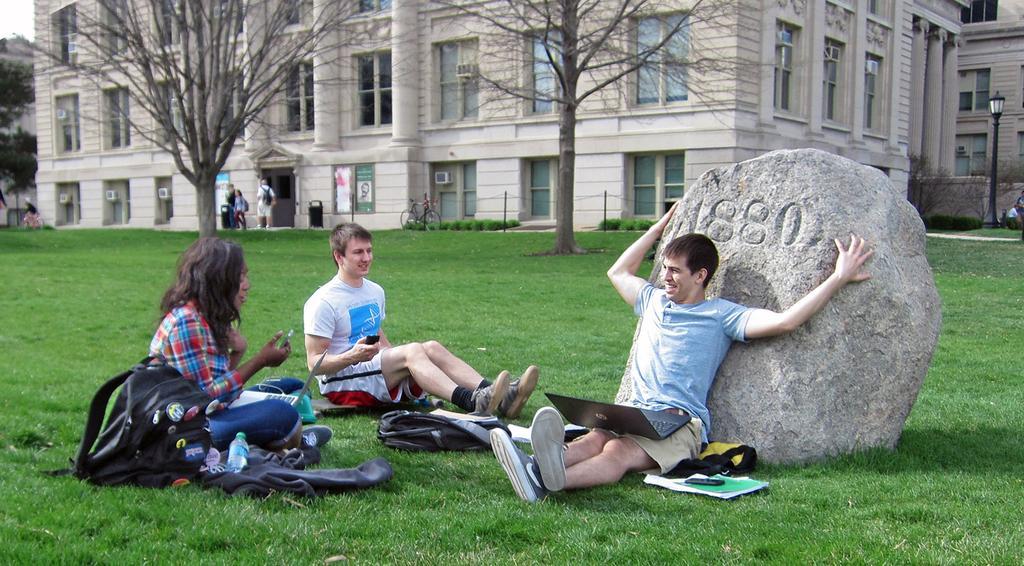Please provide a concise description of this image. In this image there are three people sitting on the grass and on the grass there are stones, books, mobile phone, water bottle and bags. In the background there are trees and also buildings and also few people. Light poles and bicycle are visible in this image. 